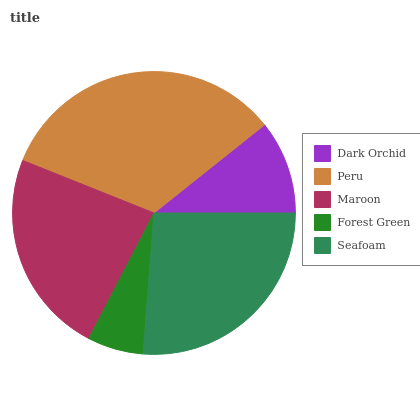Is Forest Green the minimum?
Answer yes or no. Yes. Is Peru the maximum?
Answer yes or no. Yes. Is Maroon the minimum?
Answer yes or no. No. Is Maroon the maximum?
Answer yes or no. No. Is Peru greater than Maroon?
Answer yes or no. Yes. Is Maroon less than Peru?
Answer yes or no. Yes. Is Maroon greater than Peru?
Answer yes or no. No. Is Peru less than Maroon?
Answer yes or no. No. Is Maroon the high median?
Answer yes or no. Yes. Is Maroon the low median?
Answer yes or no. Yes. Is Seafoam the high median?
Answer yes or no. No. Is Seafoam the low median?
Answer yes or no. No. 